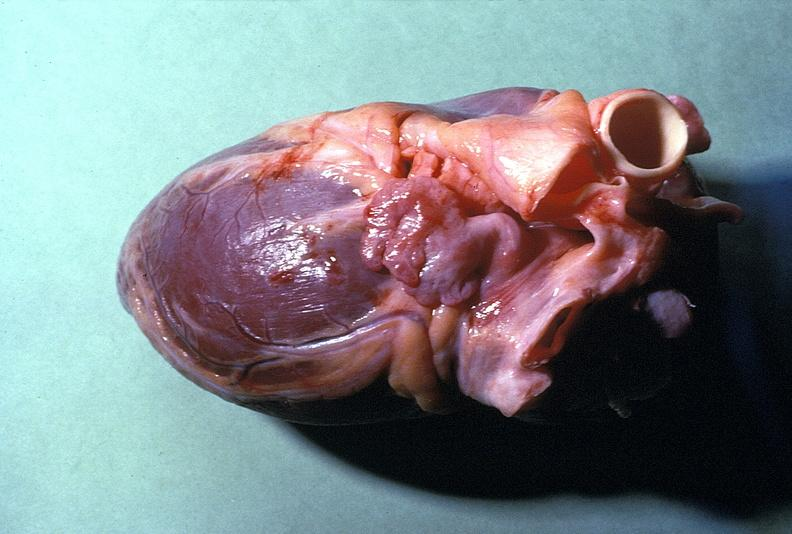does this image show normal cardiovascular?
Answer the question using a single word or phrase. Yes 